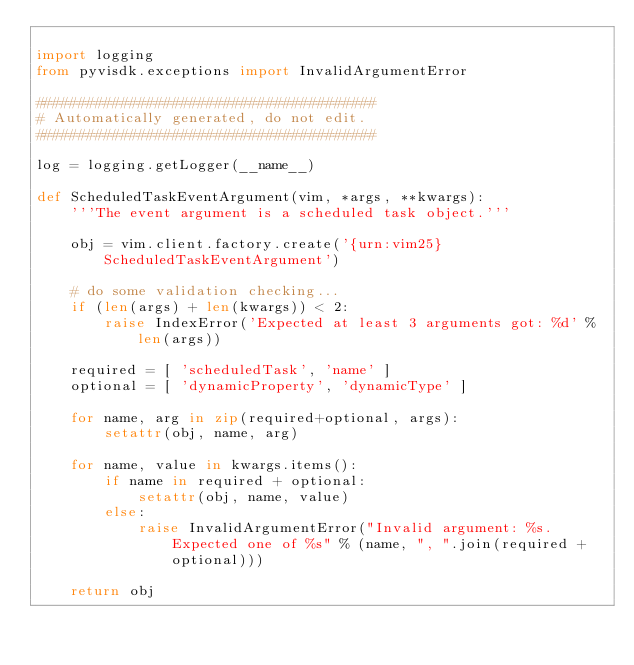Convert code to text. <code><loc_0><loc_0><loc_500><loc_500><_Python_>
import logging
from pyvisdk.exceptions import InvalidArgumentError

########################################
# Automatically generated, do not edit.
########################################

log = logging.getLogger(__name__)

def ScheduledTaskEventArgument(vim, *args, **kwargs):
    '''The event argument is a scheduled task object.'''

    obj = vim.client.factory.create('{urn:vim25}ScheduledTaskEventArgument')

    # do some validation checking...
    if (len(args) + len(kwargs)) < 2:
        raise IndexError('Expected at least 3 arguments got: %d' % len(args))

    required = [ 'scheduledTask', 'name' ]
    optional = [ 'dynamicProperty', 'dynamicType' ]

    for name, arg in zip(required+optional, args):
        setattr(obj, name, arg)

    for name, value in kwargs.items():
        if name in required + optional:
            setattr(obj, name, value)
        else:
            raise InvalidArgumentError("Invalid argument: %s.  Expected one of %s" % (name, ", ".join(required + optional)))

    return obj
</code> 